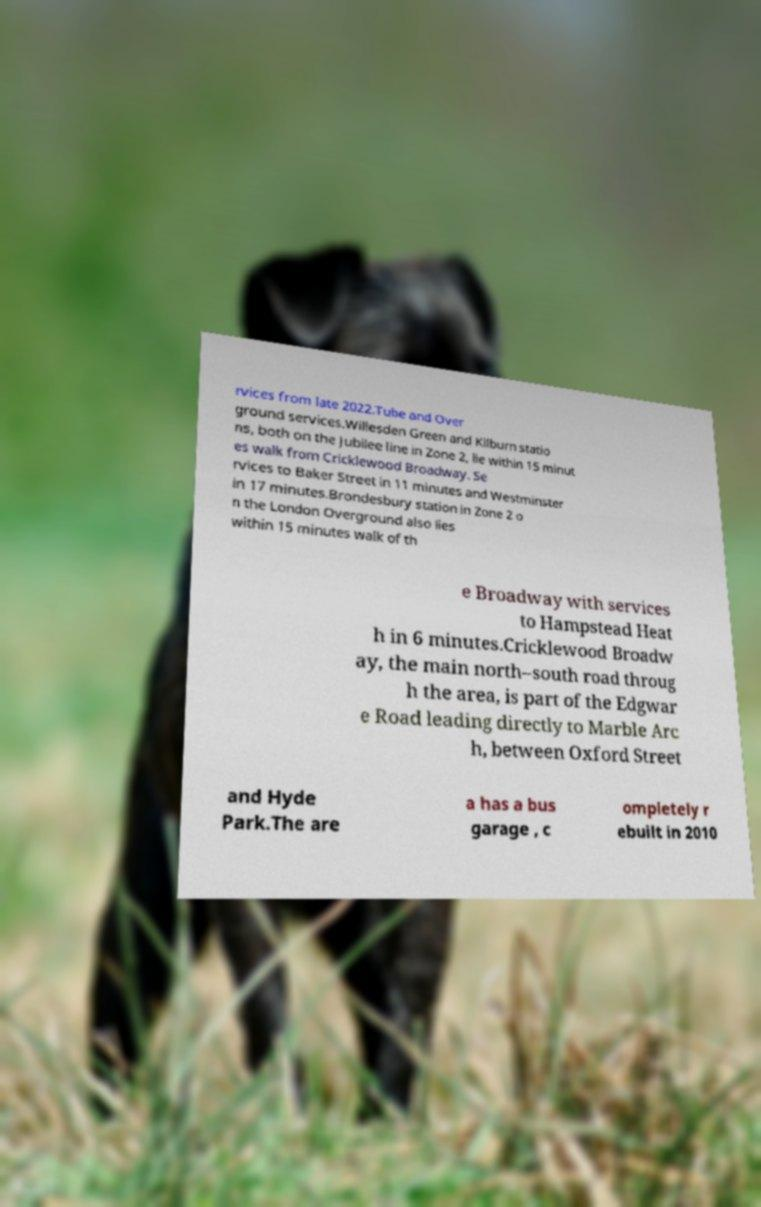Please identify and transcribe the text found in this image. rvices from late 2022.Tube and Over ground services.Willesden Green and Kilburn statio ns, both on the Jubilee line in Zone 2, lie within 15 minut es walk from Cricklewood Broadway. Se rvices to Baker Street in 11 minutes and Westminster in 17 minutes.Brondesbury station in Zone 2 o n the London Overground also lies within 15 minutes walk of th e Broadway with services to Hampstead Heat h in 6 minutes.Cricklewood Broadw ay, the main north–south road throug h the area, is part of the Edgwar e Road leading directly to Marble Arc h, between Oxford Street and Hyde Park.The are a has a bus garage , c ompletely r ebuilt in 2010 